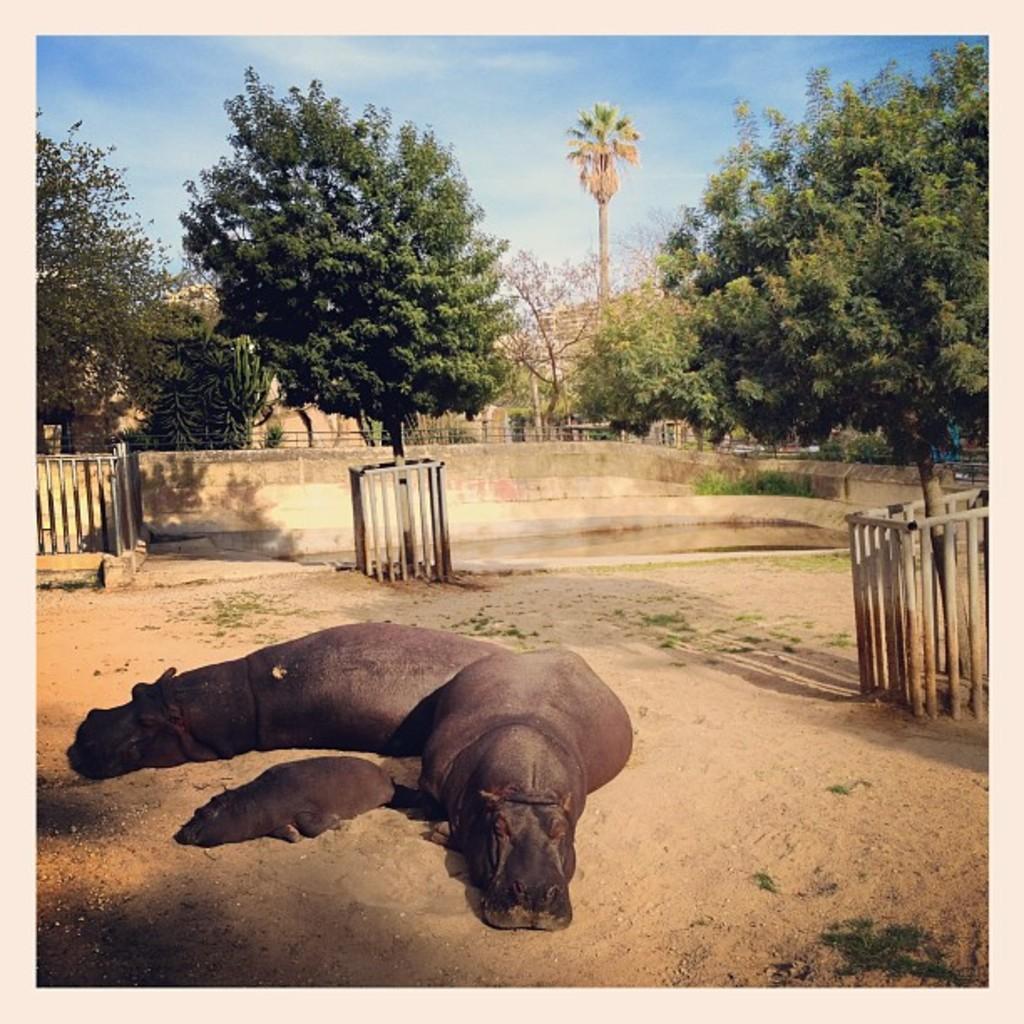Can you describe this image briefly? This picture is clicked outside. On the left we can see the group of animals seems to be lying on the ground and we can see the wooden sticks and the trees. In the background there is a sky and the trees. 